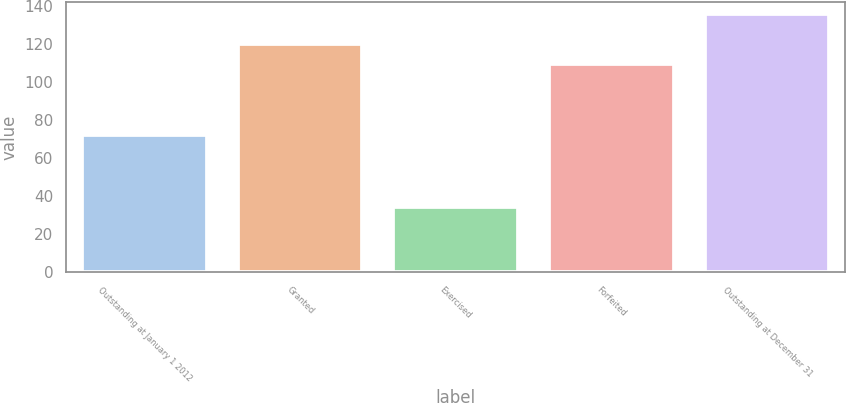<chart> <loc_0><loc_0><loc_500><loc_500><bar_chart><fcel>Outstanding at January 1 2012<fcel>Granted<fcel>Exercised<fcel>Forfeited<fcel>Outstanding at December 31<nl><fcel>72.34<fcel>119.78<fcel>34.57<fcel>109.68<fcel>135.53<nl></chart> 